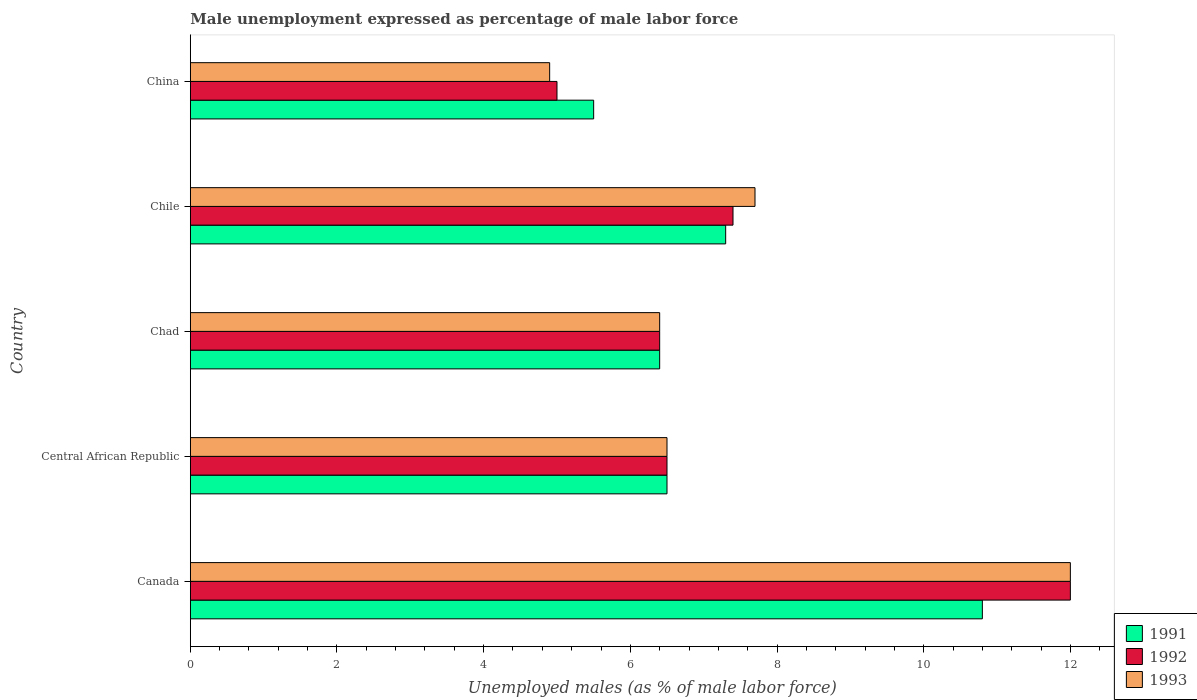How many groups of bars are there?
Keep it short and to the point. 5. How many bars are there on the 2nd tick from the top?
Keep it short and to the point. 3. How many bars are there on the 2nd tick from the bottom?
Your answer should be very brief. 3. What is the label of the 3rd group of bars from the top?
Make the answer very short. Chad. In how many cases, is the number of bars for a given country not equal to the number of legend labels?
Your answer should be very brief. 0. What is the unemployment in males in in 1991 in Canada?
Offer a terse response. 10.8. Across all countries, what is the maximum unemployment in males in in 1993?
Make the answer very short. 12. In which country was the unemployment in males in in 1993 minimum?
Provide a short and direct response. China. What is the total unemployment in males in in 1993 in the graph?
Your answer should be very brief. 37.5. What is the difference between the unemployment in males in in 1993 in Central African Republic and that in Chad?
Give a very brief answer. 0.1. What is the difference between the unemployment in males in in 1993 in China and the unemployment in males in in 1992 in Chile?
Your answer should be very brief. -2.5. What is the average unemployment in males in in 1992 per country?
Offer a very short reply. 7.46. What is the difference between the unemployment in males in in 1992 and unemployment in males in in 1993 in China?
Give a very brief answer. 0.1. In how many countries, is the unemployment in males in in 1993 greater than 5.6 %?
Your answer should be compact. 4. What is the ratio of the unemployment in males in in 1992 in Chad to that in China?
Offer a very short reply. 1.28. Is the unemployment in males in in 1992 in Canada less than that in Central African Republic?
Ensure brevity in your answer.  No. What is the difference between the highest and the second highest unemployment in males in in 1991?
Give a very brief answer. 3.5. What is the difference between the highest and the lowest unemployment in males in in 1993?
Make the answer very short. 7.1. Is the sum of the unemployment in males in in 1992 in Canada and Central African Republic greater than the maximum unemployment in males in in 1993 across all countries?
Offer a very short reply. Yes. What does the 1st bar from the bottom in Chile represents?
Provide a succinct answer. 1991. Are all the bars in the graph horizontal?
Make the answer very short. Yes. Does the graph contain any zero values?
Provide a succinct answer. No. Does the graph contain grids?
Offer a very short reply. No. Where does the legend appear in the graph?
Offer a very short reply. Bottom right. How many legend labels are there?
Your response must be concise. 3. How are the legend labels stacked?
Make the answer very short. Vertical. What is the title of the graph?
Offer a terse response. Male unemployment expressed as percentage of male labor force. Does "1972" appear as one of the legend labels in the graph?
Make the answer very short. No. What is the label or title of the X-axis?
Give a very brief answer. Unemployed males (as % of male labor force). What is the label or title of the Y-axis?
Your response must be concise. Country. What is the Unemployed males (as % of male labor force) in 1991 in Canada?
Give a very brief answer. 10.8. What is the Unemployed males (as % of male labor force) of 1993 in Canada?
Provide a short and direct response. 12. What is the Unemployed males (as % of male labor force) in 1991 in Central African Republic?
Give a very brief answer. 6.5. What is the Unemployed males (as % of male labor force) in 1992 in Central African Republic?
Keep it short and to the point. 6.5. What is the Unemployed males (as % of male labor force) of 1991 in Chad?
Offer a very short reply. 6.4. What is the Unemployed males (as % of male labor force) in 1992 in Chad?
Provide a succinct answer. 6.4. What is the Unemployed males (as % of male labor force) in 1993 in Chad?
Ensure brevity in your answer.  6.4. What is the Unemployed males (as % of male labor force) in 1991 in Chile?
Ensure brevity in your answer.  7.3. What is the Unemployed males (as % of male labor force) of 1992 in Chile?
Provide a succinct answer. 7.4. What is the Unemployed males (as % of male labor force) in 1993 in Chile?
Your response must be concise. 7.7. What is the Unemployed males (as % of male labor force) of 1991 in China?
Your answer should be very brief. 5.5. What is the Unemployed males (as % of male labor force) in 1992 in China?
Offer a terse response. 5. What is the Unemployed males (as % of male labor force) in 1993 in China?
Offer a very short reply. 4.9. Across all countries, what is the maximum Unemployed males (as % of male labor force) of 1991?
Your response must be concise. 10.8. Across all countries, what is the maximum Unemployed males (as % of male labor force) of 1992?
Your answer should be very brief. 12. Across all countries, what is the minimum Unemployed males (as % of male labor force) of 1993?
Provide a short and direct response. 4.9. What is the total Unemployed males (as % of male labor force) of 1991 in the graph?
Offer a very short reply. 36.5. What is the total Unemployed males (as % of male labor force) in 1992 in the graph?
Ensure brevity in your answer.  37.3. What is the total Unemployed males (as % of male labor force) of 1993 in the graph?
Provide a succinct answer. 37.5. What is the difference between the Unemployed males (as % of male labor force) in 1993 in Canada and that in Central African Republic?
Give a very brief answer. 5.5. What is the difference between the Unemployed males (as % of male labor force) in 1992 in Canada and that in Chad?
Your answer should be very brief. 5.6. What is the difference between the Unemployed males (as % of male labor force) of 1991 in Canada and that in Chile?
Your answer should be compact. 3.5. What is the difference between the Unemployed males (as % of male labor force) in 1992 in Canada and that in Chile?
Provide a succinct answer. 4.6. What is the difference between the Unemployed males (as % of male labor force) in 1992 in Canada and that in China?
Provide a succinct answer. 7. What is the difference between the Unemployed males (as % of male labor force) in 1991 in Central African Republic and that in Chad?
Give a very brief answer. 0.1. What is the difference between the Unemployed males (as % of male labor force) in 1992 in Central African Republic and that in China?
Keep it short and to the point. 1.5. What is the difference between the Unemployed males (as % of male labor force) of 1991 in Chad and that in Chile?
Offer a very short reply. -0.9. What is the difference between the Unemployed males (as % of male labor force) of 1993 in Chad and that in Chile?
Your answer should be very brief. -1.3. What is the difference between the Unemployed males (as % of male labor force) in 1991 in Chad and that in China?
Provide a short and direct response. 0.9. What is the difference between the Unemployed males (as % of male labor force) in 1992 in Chad and that in China?
Provide a short and direct response. 1.4. What is the difference between the Unemployed males (as % of male labor force) in 1992 in Chile and that in China?
Your answer should be very brief. 2.4. What is the difference between the Unemployed males (as % of male labor force) of 1993 in Chile and that in China?
Keep it short and to the point. 2.8. What is the difference between the Unemployed males (as % of male labor force) of 1991 in Canada and the Unemployed males (as % of male labor force) of 1992 in Chad?
Offer a terse response. 4.4. What is the difference between the Unemployed males (as % of male labor force) in 1991 in Canada and the Unemployed males (as % of male labor force) in 1993 in Chad?
Give a very brief answer. 4.4. What is the difference between the Unemployed males (as % of male labor force) of 1992 in Canada and the Unemployed males (as % of male labor force) of 1993 in Chad?
Provide a succinct answer. 5.6. What is the difference between the Unemployed males (as % of male labor force) in 1991 in Canada and the Unemployed males (as % of male labor force) in 1993 in Chile?
Your answer should be very brief. 3.1. What is the difference between the Unemployed males (as % of male labor force) in 1991 in Central African Republic and the Unemployed males (as % of male labor force) in 1992 in Chad?
Give a very brief answer. 0.1. What is the difference between the Unemployed males (as % of male labor force) of 1991 in Central African Republic and the Unemployed males (as % of male labor force) of 1992 in Chile?
Offer a very short reply. -0.9. What is the difference between the Unemployed males (as % of male labor force) of 1992 in Central African Republic and the Unemployed males (as % of male labor force) of 1993 in Chile?
Make the answer very short. -1.2. What is the difference between the Unemployed males (as % of male labor force) of 1992 in Central African Republic and the Unemployed males (as % of male labor force) of 1993 in China?
Give a very brief answer. 1.6. What is the difference between the Unemployed males (as % of male labor force) in 1991 in Chad and the Unemployed males (as % of male labor force) in 1993 in Chile?
Make the answer very short. -1.3. What is the difference between the Unemployed males (as % of male labor force) of 1992 in Chad and the Unemployed males (as % of male labor force) of 1993 in Chile?
Offer a very short reply. -1.3. What is the difference between the Unemployed males (as % of male labor force) in 1991 in Chad and the Unemployed males (as % of male labor force) in 1993 in China?
Offer a very short reply. 1.5. What is the difference between the Unemployed males (as % of male labor force) of 1991 in Chile and the Unemployed males (as % of male labor force) of 1992 in China?
Make the answer very short. 2.3. What is the difference between the Unemployed males (as % of male labor force) in 1992 in Chile and the Unemployed males (as % of male labor force) in 1993 in China?
Provide a succinct answer. 2.5. What is the average Unemployed males (as % of male labor force) in 1991 per country?
Keep it short and to the point. 7.3. What is the average Unemployed males (as % of male labor force) of 1992 per country?
Make the answer very short. 7.46. What is the average Unemployed males (as % of male labor force) of 1993 per country?
Your answer should be very brief. 7.5. What is the difference between the Unemployed males (as % of male labor force) of 1991 and Unemployed males (as % of male labor force) of 1992 in Central African Republic?
Provide a succinct answer. 0. What is the difference between the Unemployed males (as % of male labor force) of 1991 and Unemployed males (as % of male labor force) of 1993 in Central African Republic?
Ensure brevity in your answer.  0. What is the difference between the Unemployed males (as % of male labor force) of 1992 and Unemployed males (as % of male labor force) of 1993 in Central African Republic?
Make the answer very short. 0. What is the difference between the Unemployed males (as % of male labor force) in 1991 and Unemployed males (as % of male labor force) in 1992 in Chad?
Your answer should be very brief. 0. What is the difference between the Unemployed males (as % of male labor force) of 1992 and Unemployed males (as % of male labor force) of 1993 in Chad?
Offer a very short reply. 0. What is the difference between the Unemployed males (as % of male labor force) of 1991 and Unemployed males (as % of male labor force) of 1992 in Chile?
Give a very brief answer. -0.1. What is the ratio of the Unemployed males (as % of male labor force) of 1991 in Canada to that in Central African Republic?
Offer a very short reply. 1.66. What is the ratio of the Unemployed males (as % of male labor force) of 1992 in Canada to that in Central African Republic?
Make the answer very short. 1.85. What is the ratio of the Unemployed males (as % of male labor force) of 1993 in Canada to that in Central African Republic?
Give a very brief answer. 1.85. What is the ratio of the Unemployed males (as % of male labor force) in 1991 in Canada to that in Chad?
Make the answer very short. 1.69. What is the ratio of the Unemployed males (as % of male labor force) in 1992 in Canada to that in Chad?
Offer a terse response. 1.88. What is the ratio of the Unemployed males (as % of male labor force) of 1993 in Canada to that in Chad?
Your answer should be compact. 1.88. What is the ratio of the Unemployed males (as % of male labor force) of 1991 in Canada to that in Chile?
Keep it short and to the point. 1.48. What is the ratio of the Unemployed males (as % of male labor force) in 1992 in Canada to that in Chile?
Keep it short and to the point. 1.62. What is the ratio of the Unemployed males (as % of male labor force) in 1993 in Canada to that in Chile?
Your answer should be compact. 1.56. What is the ratio of the Unemployed males (as % of male labor force) of 1991 in Canada to that in China?
Offer a very short reply. 1.96. What is the ratio of the Unemployed males (as % of male labor force) in 1993 in Canada to that in China?
Provide a succinct answer. 2.45. What is the ratio of the Unemployed males (as % of male labor force) of 1991 in Central African Republic to that in Chad?
Keep it short and to the point. 1.02. What is the ratio of the Unemployed males (as % of male labor force) of 1992 in Central African Republic to that in Chad?
Offer a terse response. 1.02. What is the ratio of the Unemployed males (as % of male labor force) of 1993 in Central African Republic to that in Chad?
Offer a terse response. 1.02. What is the ratio of the Unemployed males (as % of male labor force) in 1991 in Central African Republic to that in Chile?
Provide a short and direct response. 0.89. What is the ratio of the Unemployed males (as % of male labor force) in 1992 in Central African Republic to that in Chile?
Give a very brief answer. 0.88. What is the ratio of the Unemployed males (as % of male labor force) in 1993 in Central African Republic to that in Chile?
Your answer should be very brief. 0.84. What is the ratio of the Unemployed males (as % of male labor force) in 1991 in Central African Republic to that in China?
Your response must be concise. 1.18. What is the ratio of the Unemployed males (as % of male labor force) in 1993 in Central African Republic to that in China?
Your response must be concise. 1.33. What is the ratio of the Unemployed males (as % of male labor force) of 1991 in Chad to that in Chile?
Your answer should be compact. 0.88. What is the ratio of the Unemployed males (as % of male labor force) in 1992 in Chad to that in Chile?
Your response must be concise. 0.86. What is the ratio of the Unemployed males (as % of male labor force) of 1993 in Chad to that in Chile?
Keep it short and to the point. 0.83. What is the ratio of the Unemployed males (as % of male labor force) in 1991 in Chad to that in China?
Provide a succinct answer. 1.16. What is the ratio of the Unemployed males (as % of male labor force) in 1992 in Chad to that in China?
Your response must be concise. 1.28. What is the ratio of the Unemployed males (as % of male labor force) of 1993 in Chad to that in China?
Give a very brief answer. 1.31. What is the ratio of the Unemployed males (as % of male labor force) in 1991 in Chile to that in China?
Provide a short and direct response. 1.33. What is the ratio of the Unemployed males (as % of male labor force) in 1992 in Chile to that in China?
Keep it short and to the point. 1.48. What is the ratio of the Unemployed males (as % of male labor force) of 1993 in Chile to that in China?
Your answer should be very brief. 1.57. What is the difference between the highest and the second highest Unemployed males (as % of male labor force) in 1992?
Provide a short and direct response. 4.6. What is the difference between the highest and the lowest Unemployed males (as % of male labor force) of 1991?
Give a very brief answer. 5.3. What is the difference between the highest and the lowest Unemployed males (as % of male labor force) in 1993?
Offer a terse response. 7.1. 